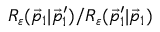<formula> <loc_0><loc_0><loc_500><loc_500>R _ { \varepsilon } ( \vec { p } _ { 1 } | \vec { p } _ { 1 } ^ { \prime } ) / R _ { \varepsilon } ( \vec { p } _ { 1 } ^ { \prime } | \vec { p } _ { 1 } )</formula> 